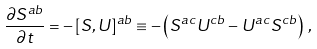<formula> <loc_0><loc_0><loc_500><loc_500>\frac { \partial S ^ { a b } } { \partial t } = - \left [ S , U \right ] ^ { a b } \equiv - \left ( S ^ { a c } U ^ { c b } - U ^ { a c } S ^ { c b } \right ) \, ,</formula> 